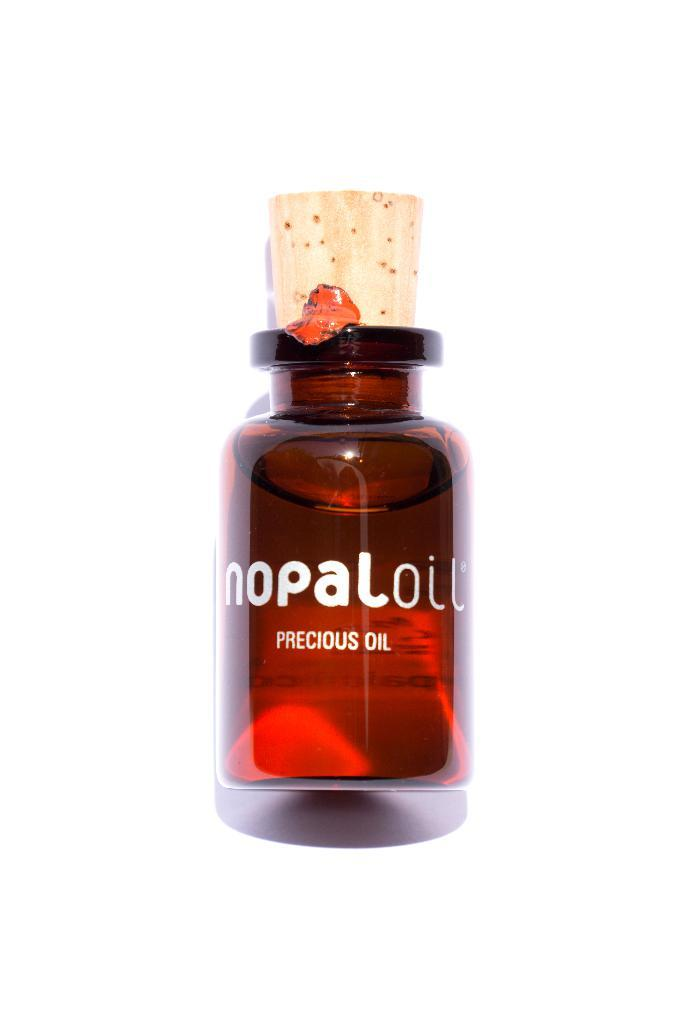What color is the bottle in the image? The bottle in the image is red. What feature is present on the bottle to keep its contents secure? The bottle has a cork. Is there any writing or design on the bottle? Yes, there is text on the bottle. How many shoes are visible in the image? There are no shoes present in the image; it features a red bottle with a cork and text. 